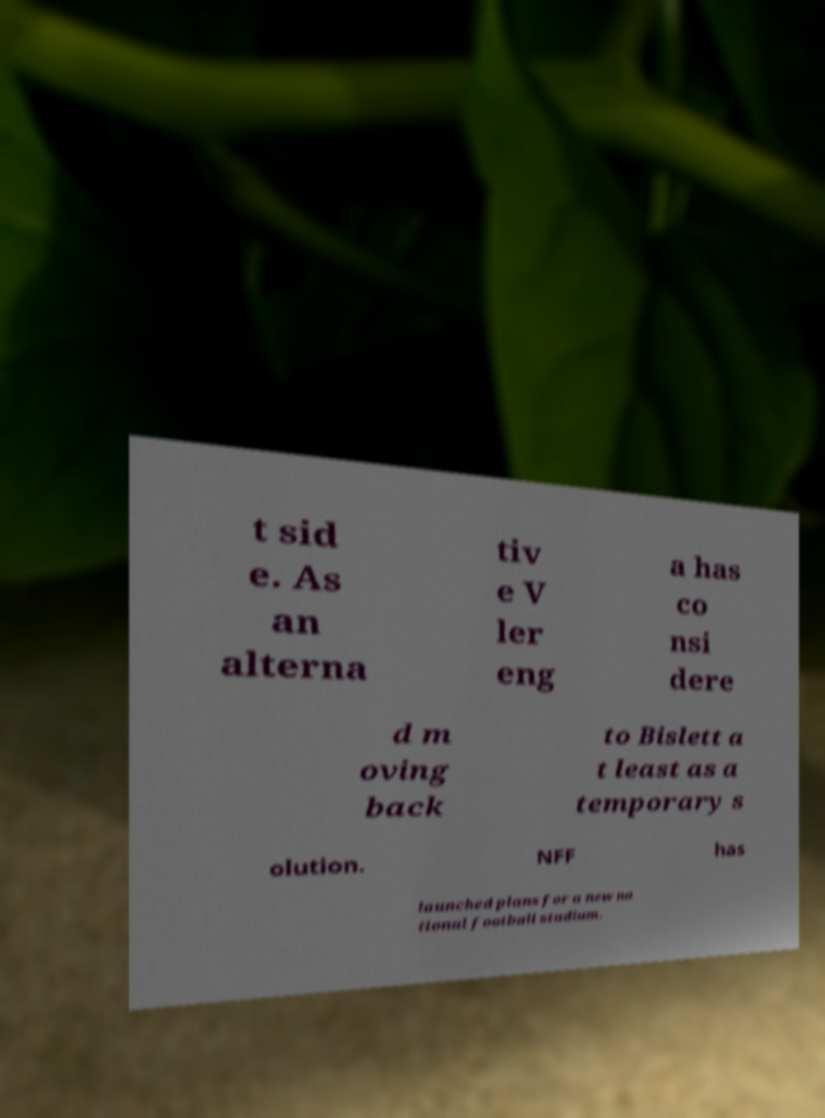What messages or text are displayed in this image? I need them in a readable, typed format. t sid e. As an alterna tiv e V ler eng a has co nsi dere d m oving back to Bislett a t least as a temporary s olution. NFF has launched plans for a new na tional football stadium. 